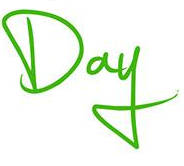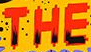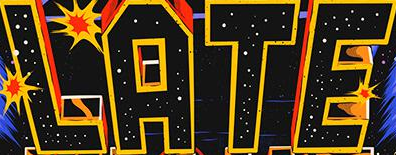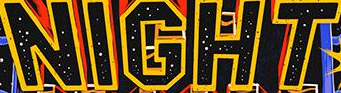Transcribe the words shown in these images in order, separated by a semicolon. Day; THE; LATE; NIGHT 